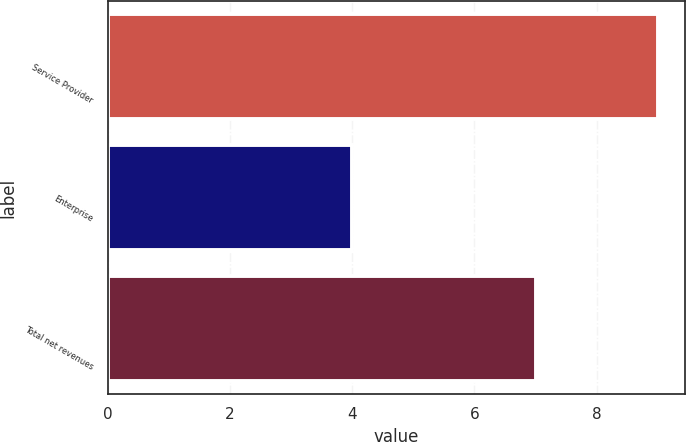Convert chart to OTSL. <chart><loc_0><loc_0><loc_500><loc_500><bar_chart><fcel>Service Provider<fcel>Enterprise<fcel>Total net revenues<nl><fcel>9<fcel>4<fcel>7<nl></chart> 